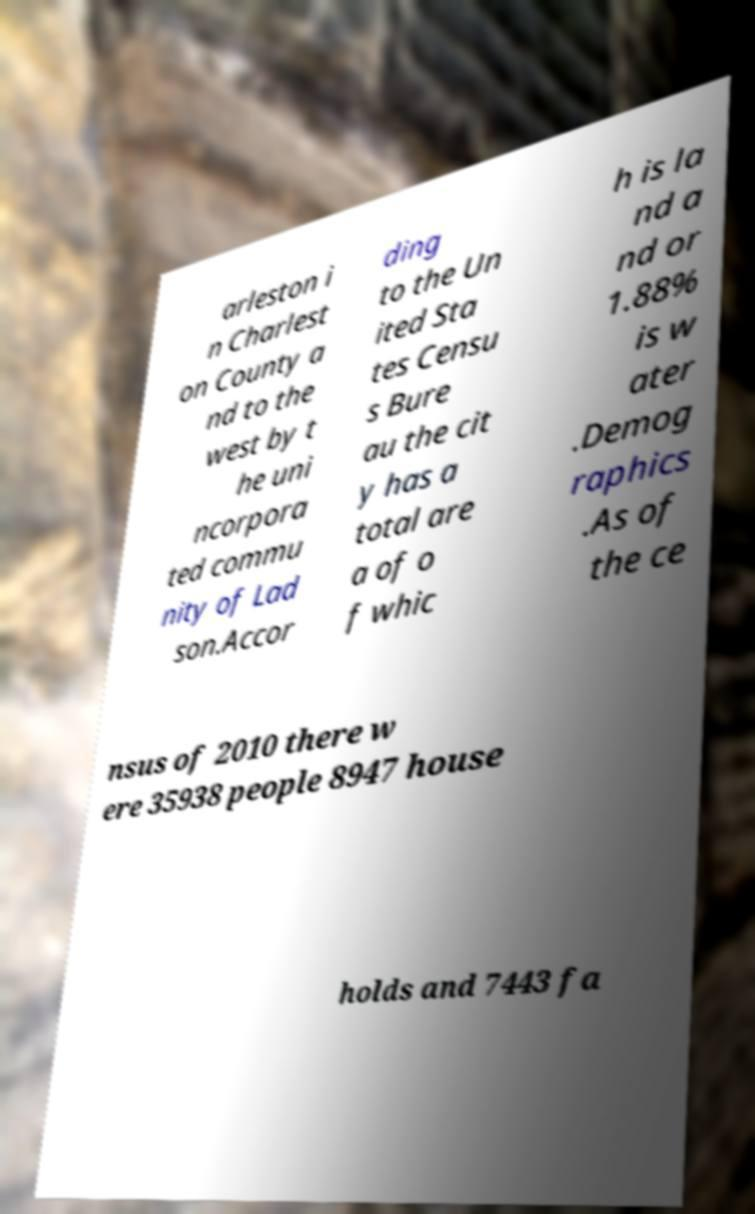Please read and relay the text visible in this image. What does it say? arleston i n Charlest on County a nd to the west by t he uni ncorpora ted commu nity of Lad son.Accor ding to the Un ited Sta tes Censu s Bure au the cit y has a total are a of o f whic h is la nd a nd or 1.88% is w ater .Demog raphics .As of the ce nsus of 2010 there w ere 35938 people 8947 house holds and 7443 fa 